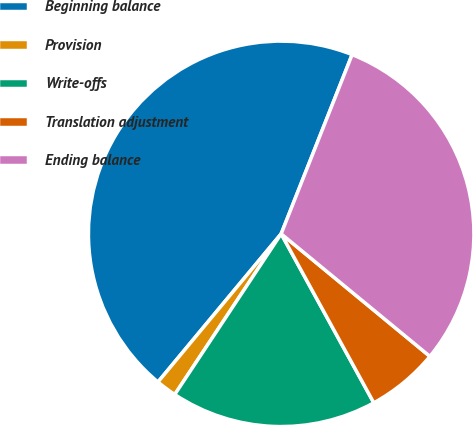Convert chart. <chart><loc_0><loc_0><loc_500><loc_500><pie_chart><fcel>Beginning balance<fcel>Provision<fcel>Write-offs<fcel>Translation adjustment<fcel>Ending balance<nl><fcel>44.96%<fcel>1.73%<fcel>17.29%<fcel>6.05%<fcel>29.97%<nl></chart> 